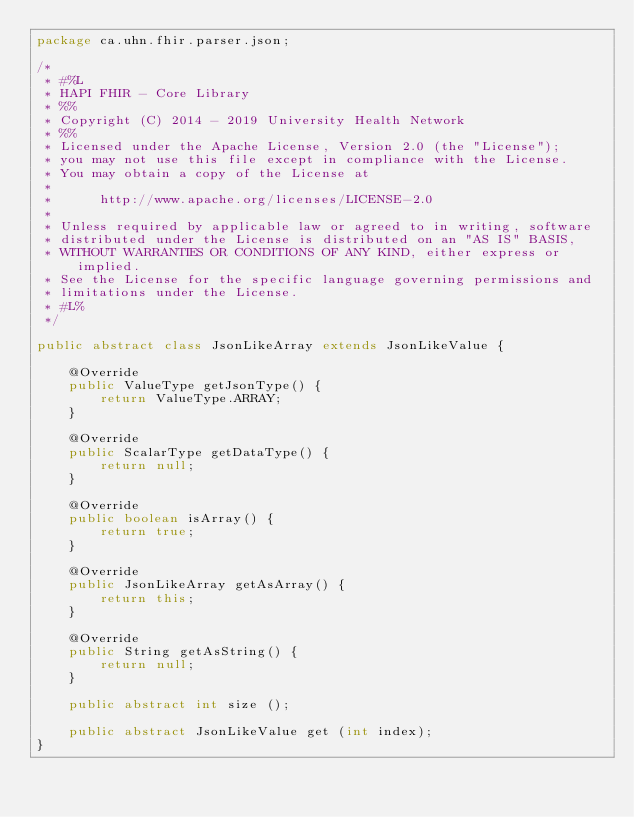<code> <loc_0><loc_0><loc_500><loc_500><_Java_>package ca.uhn.fhir.parser.json;

/*
 * #%L
 * HAPI FHIR - Core Library
 * %%
 * Copyright (C) 2014 - 2019 University Health Network
 * %%
 * Licensed under the Apache License, Version 2.0 (the "License");
 * you may not use this file except in compliance with the License.
 * You may obtain a copy of the License at
 * 
 *      http://www.apache.org/licenses/LICENSE-2.0
 * 
 * Unless required by applicable law or agreed to in writing, software
 * distributed under the License is distributed on an "AS IS" BASIS,
 * WITHOUT WARRANTIES OR CONDITIONS OF ANY KIND, either express or implied.
 * See the License for the specific language governing permissions and
 * limitations under the License.
 * #L%
 */

public abstract class JsonLikeArray extends JsonLikeValue {

	@Override
	public ValueType getJsonType() {
		return ValueType.ARRAY;
	}
	
	@Override
	public ScalarType getDataType() {
		return null;
	}

	@Override
	public boolean isArray() {
		return true;
	}

	@Override
	public JsonLikeArray getAsArray() {
		return this;
	}

	@Override
	public String getAsString() {
		return null;
	}

	public abstract int size ();
	
	public abstract JsonLikeValue get (int index);
}
</code> 